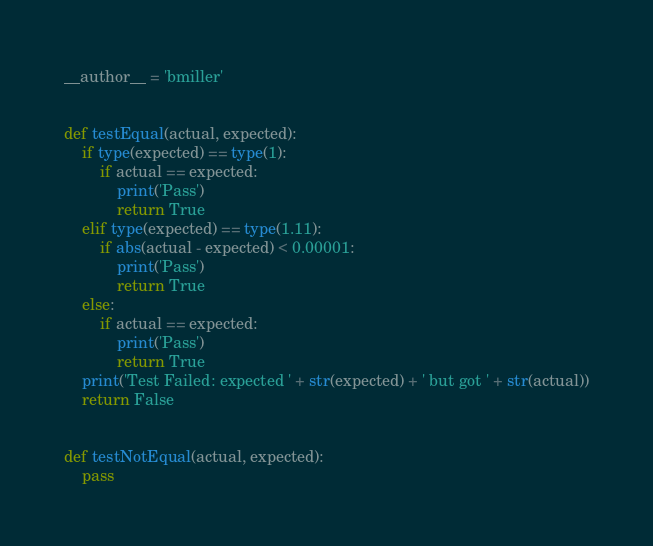<code> <loc_0><loc_0><loc_500><loc_500><_Python_>__author__ = 'bmiller'


def testEqual(actual, expected):
    if type(expected) == type(1):
        if actual == expected:
            print('Pass')
            return True
    elif type(expected) == type(1.11):
        if abs(actual - expected) < 0.00001:
            print('Pass')
            return True
    else:
        if actual == expected:
            print('Pass')
            return True
    print('Test Failed: expected ' + str(expected) + ' but got ' + str(actual))
    return False


def testNotEqual(actual, expected):
    pass
</code> 